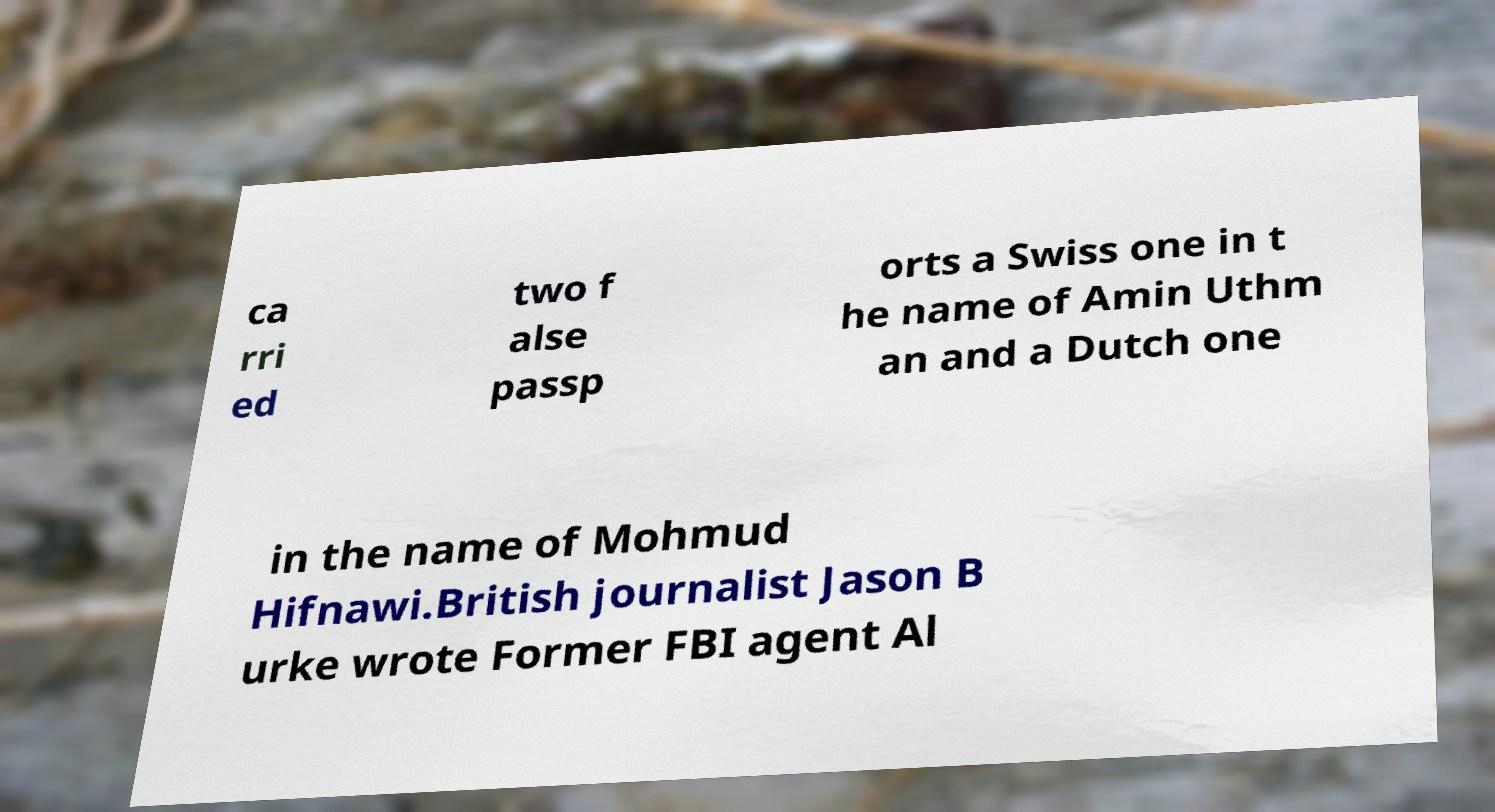There's text embedded in this image that I need extracted. Can you transcribe it verbatim? ca rri ed two f alse passp orts a Swiss one in t he name of Amin Uthm an and a Dutch one in the name of Mohmud Hifnawi.British journalist Jason B urke wrote Former FBI agent Al 